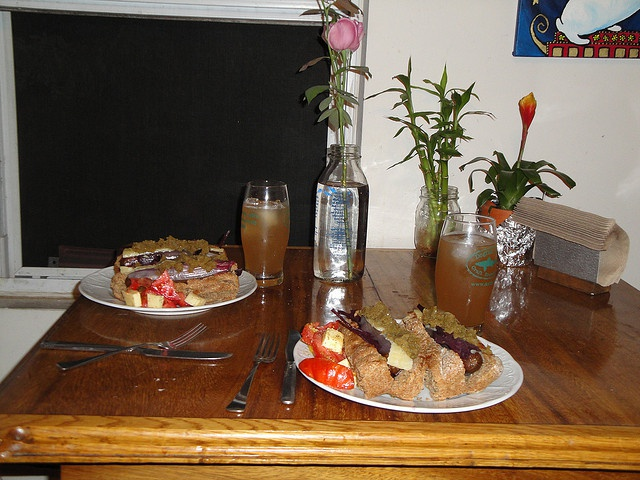Describe the objects in this image and their specific colors. I can see dining table in darkgray, maroon, olive, and black tones, tv in darkgray, black, gray, and lightgray tones, cup in darkgray, maroon, and gray tones, bottle in darkgray, gray, black, and lightgray tones, and hot dog in darkgray, tan, olive, and gray tones in this image. 